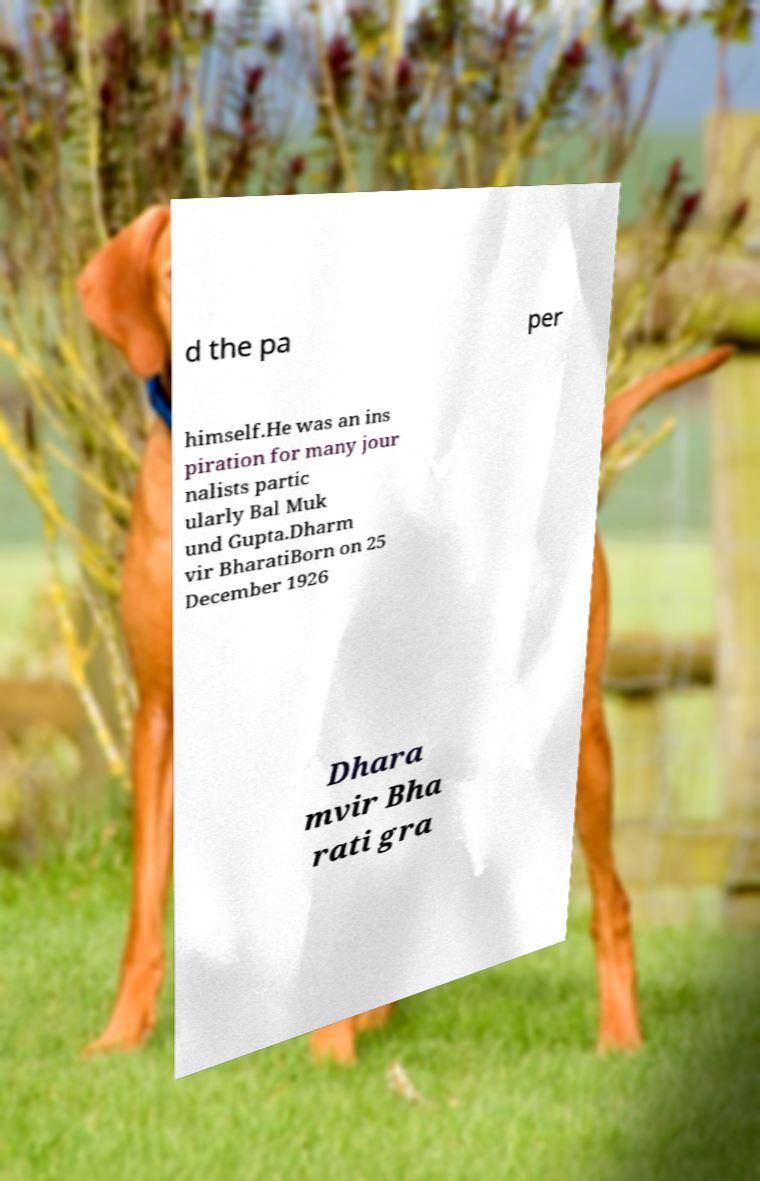I need the written content from this picture converted into text. Can you do that? d the pa per himself.He was an ins piration for many jour nalists partic ularly Bal Muk und Gupta.Dharm vir BharatiBorn on 25 December 1926 Dhara mvir Bha rati gra 